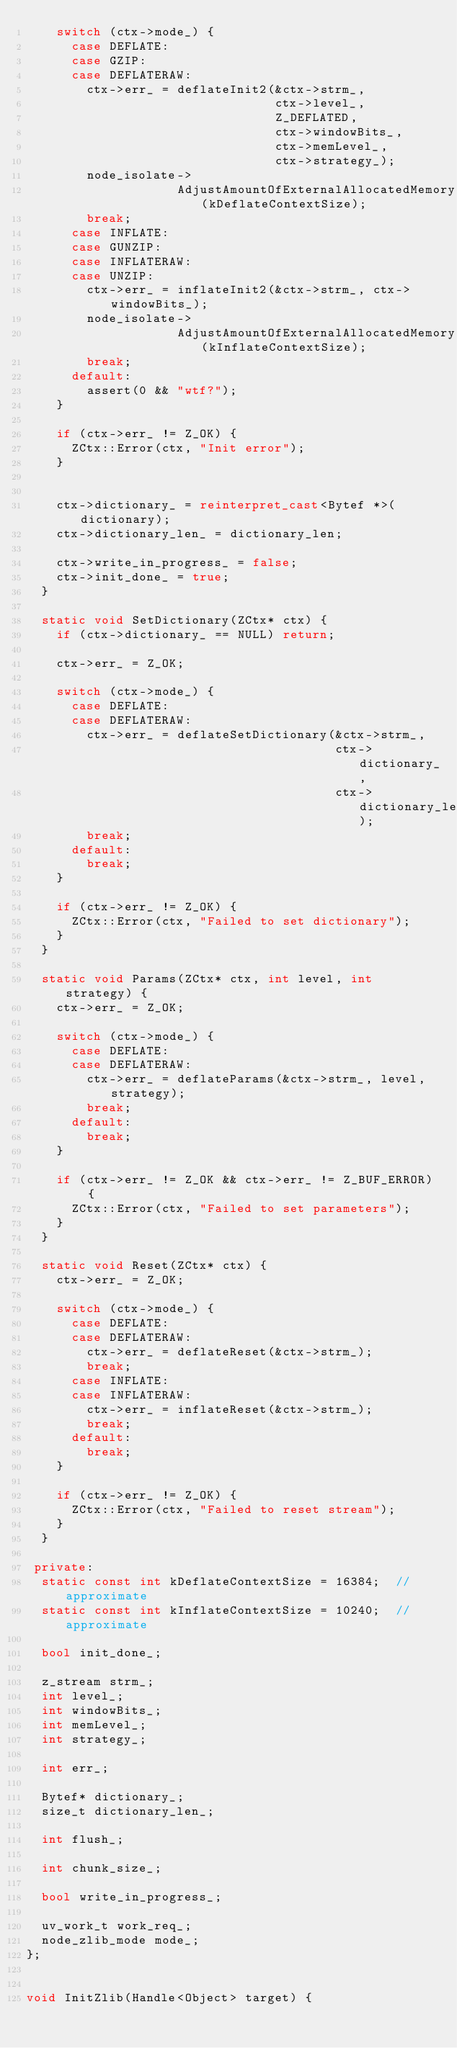Convert code to text. <code><loc_0><loc_0><loc_500><loc_500><_C++_>    switch (ctx->mode_) {
      case DEFLATE:
      case GZIP:
      case DEFLATERAW:
        ctx->err_ = deflateInit2(&ctx->strm_,
                                 ctx->level_,
                                 Z_DEFLATED,
                                 ctx->windowBits_,
                                 ctx->memLevel_,
                                 ctx->strategy_);
        node_isolate->
                    AdjustAmountOfExternalAllocatedMemory(kDeflateContextSize);
        break;
      case INFLATE:
      case GUNZIP:
      case INFLATERAW:
      case UNZIP:
        ctx->err_ = inflateInit2(&ctx->strm_, ctx->windowBits_);
        node_isolate->
                    AdjustAmountOfExternalAllocatedMemory(kInflateContextSize);
        break;
      default:
        assert(0 && "wtf?");
    }

    if (ctx->err_ != Z_OK) {
      ZCtx::Error(ctx, "Init error");
    }


    ctx->dictionary_ = reinterpret_cast<Bytef *>(dictionary);
    ctx->dictionary_len_ = dictionary_len;

    ctx->write_in_progress_ = false;
    ctx->init_done_ = true;
  }

  static void SetDictionary(ZCtx* ctx) {
    if (ctx->dictionary_ == NULL) return;

    ctx->err_ = Z_OK;

    switch (ctx->mode_) {
      case DEFLATE:
      case DEFLATERAW:
        ctx->err_ = deflateSetDictionary(&ctx->strm_,
                                         ctx->dictionary_,
                                         ctx->dictionary_len_);
        break;
      default:
        break;
    }

    if (ctx->err_ != Z_OK) {
      ZCtx::Error(ctx, "Failed to set dictionary");
    }
  }

  static void Params(ZCtx* ctx, int level, int strategy) {
    ctx->err_ = Z_OK;

    switch (ctx->mode_) {
      case DEFLATE:
      case DEFLATERAW:
        ctx->err_ = deflateParams(&ctx->strm_, level, strategy);
        break;
      default:
        break;
    }

    if (ctx->err_ != Z_OK && ctx->err_ != Z_BUF_ERROR) {
      ZCtx::Error(ctx, "Failed to set parameters");
    }
  }

  static void Reset(ZCtx* ctx) {
    ctx->err_ = Z_OK;

    switch (ctx->mode_) {
      case DEFLATE:
      case DEFLATERAW:
        ctx->err_ = deflateReset(&ctx->strm_);
        break;
      case INFLATE:
      case INFLATERAW:
        ctx->err_ = inflateReset(&ctx->strm_);
        break;
      default:
        break;
    }

    if (ctx->err_ != Z_OK) {
      ZCtx::Error(ctx, "Failed to reset stream");
    }
  }

 private:
  static const int kDeflateContextSize = 16384;  // approximate
  static const int kInflateContextSize = 10240;  // approximate

  bool init_done_;

  z_stream strm_;
  int level_;
  int windowBits_;
  int memLevel_;
  int strategy_;

  int err_;

  Bytef* dictionary_;
  size_t dictionary_len_;

  int flush_;

  int chunk_size_;

  bool write_in_progress_;

  uv_work_t work_req_;
  node_zlib_mode mode_;
};


void InitZlib(Handle<Object> target) {</code> 